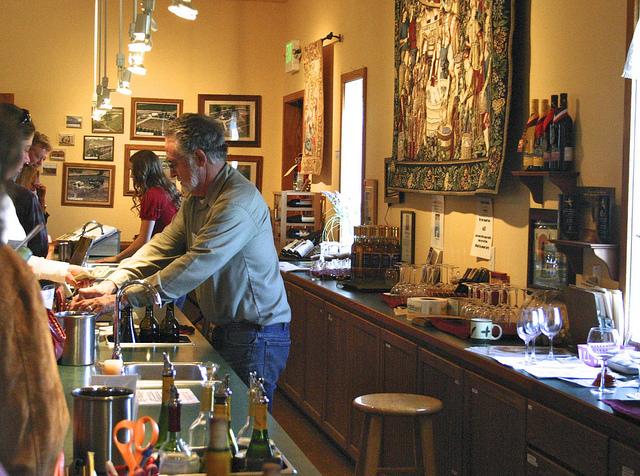What are they selling here?
Quick response, please. Wine. What color are the scissors in the cup?
Be succinct. Orange. What color are the walls?
Be succinct. Yellow. 